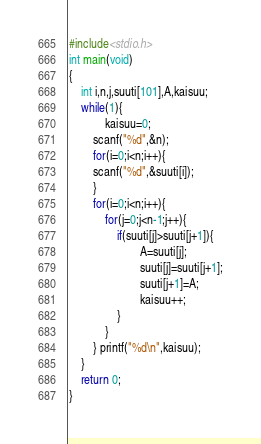<code> <loc_0><loc_0><loc_500><loc_500><_C_>#include<stdio.h>
int main(void)
{
    int i,n,j,suuti[101],A,kaisuu;
    while(1){
            kaisuu=0;
        scanf("%d",&n);
        for(i=0;i<n;i++){
        scanf("%d",&suuti[i]);
        }
        for(i=0;i<n;i++){
            for(j=0;j<n-1;j++){
                if(suuti[j]>suuti[j+1]){
                        A=suuti[j];
                        suuti[j]=suuti[j+1];
                        suuti[j+1]=A;
                        kaisuu++;
                }
            }
        } printf("%d\n",kaisuu);
    }
    return 0;
}</code> 